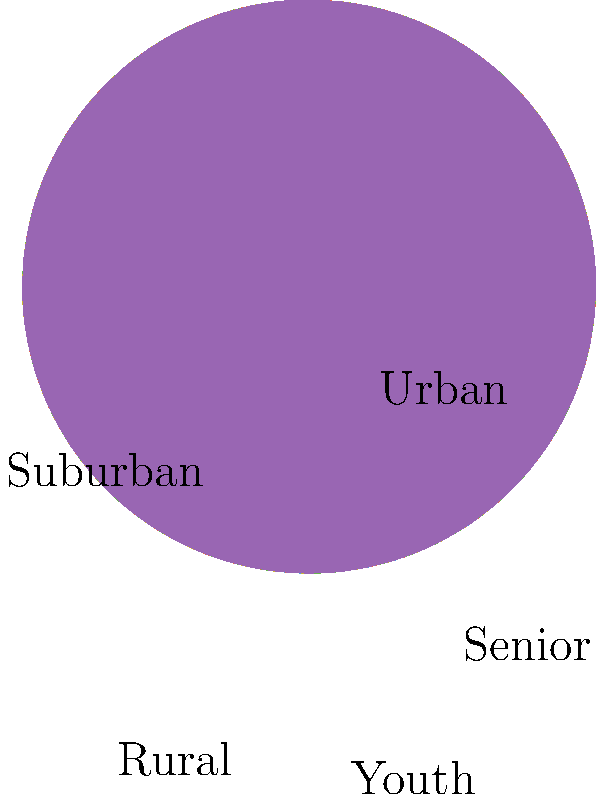As a presidential candidate, you're analyzing your demographic support distribution. The pie chart shows the breakdown of your supporters. Which two demographic groups combined make up 55% of your total support base? To solve this problem, we need to follow these steps:

1. Identify the percentages for each demographic group:
   Urban: 30%
   Suburban: 25%
   Rural: 20%
   Youth: 15%
   Senior: 10%

2. We need to find two groups that add up to 55%. Let's start with the largest group and work our way down:

   Urban (30%) + Suburban (25%) = 55%

3. We've found our answer. No other combination of two groups adds up to exactly 55%.

This information is crucial for a presidential candidate as it shows where the majority of support lies. Understanding that Urban and Suburban voters make up more than half of the support base can inform campaign strategies, resource allocation, and policy focus.
Answer: Urban and Suburban 